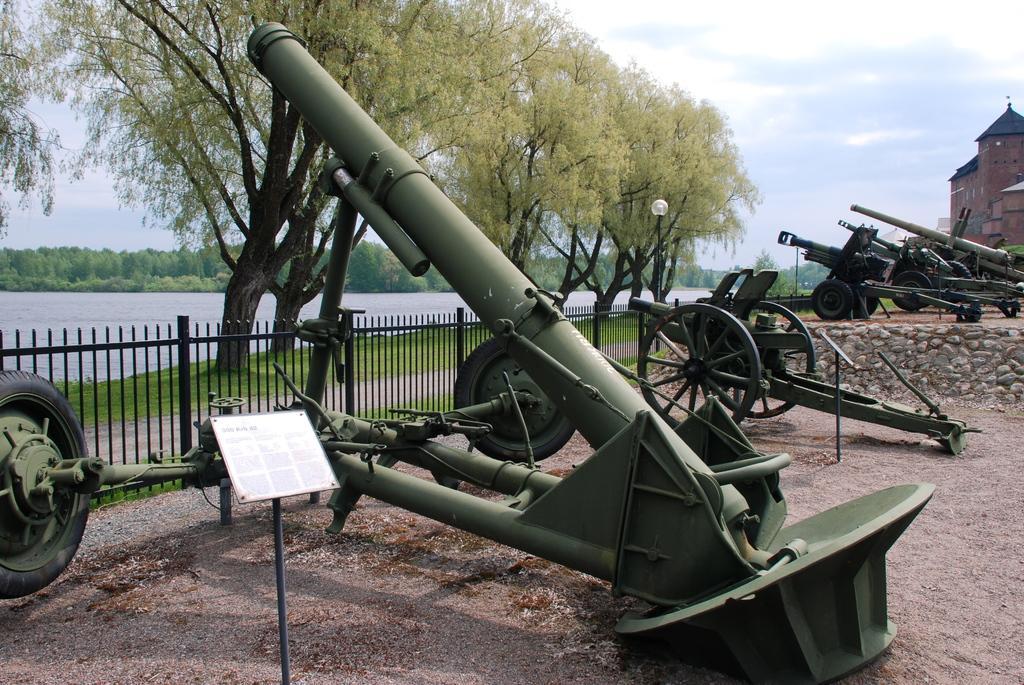Describe this image in one or two sentences. In this image we can see some canons which are on the ground there is fencing and in the background of the image there are some trees, water and clear sky and on right side of the image there are some buildings. 